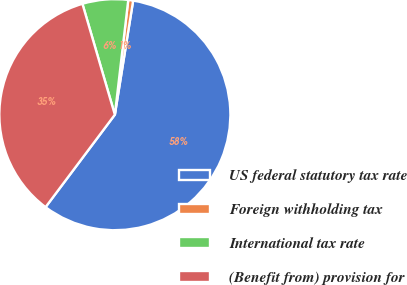<chart> <loc_0><loc_0><loc_500><loc_500><pie_chart><fcel>US federal statutory tax rate<fcel>Foreign withholding tax<fcel>International tax rate<fcel>(Benefit from) provision for<nl><fcel>57.7%<fcel>0.68%<fcel>6.38%<fcel>35.23%<nl></chart> 